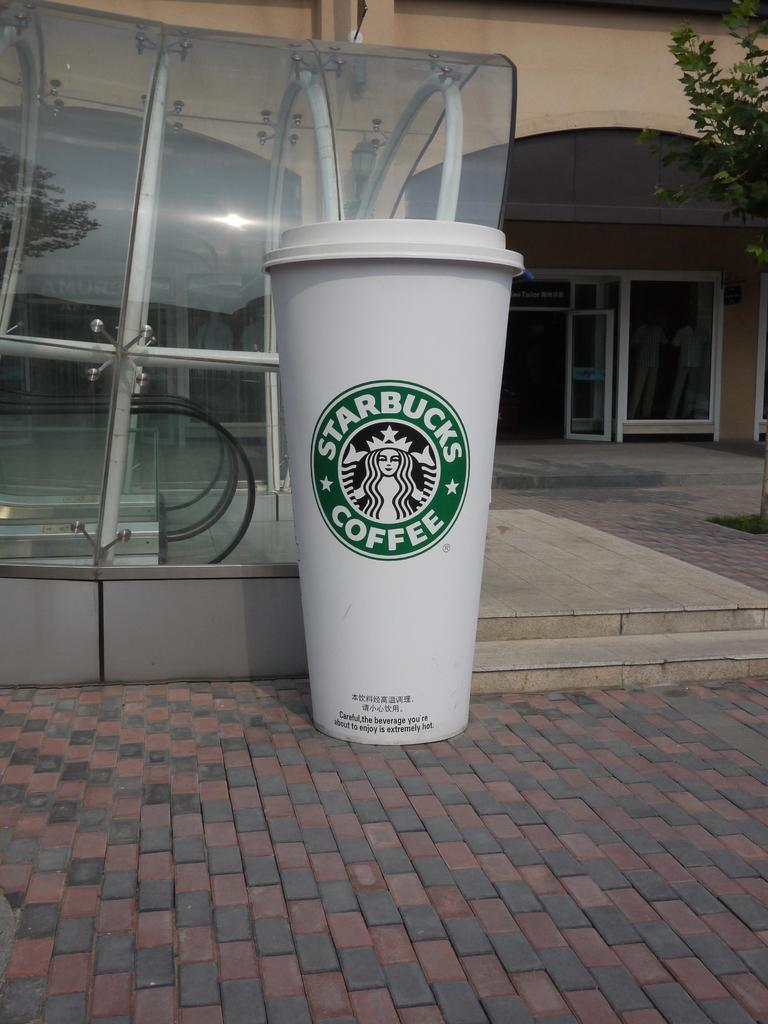What type of cup is visible in the image? There is a white Starbucks cup in the image. Where is the cup located? The cup is placed on the floor. What can be seen in the background of the image? There is a glass shed and a building in the background of the image. Is there any entrance visible in the background? Yes, there is a glass door in the background of the image. How does the mountain compare to the cup in the image? There is no mountain present in the image, so it cannot be compared to the cup. 